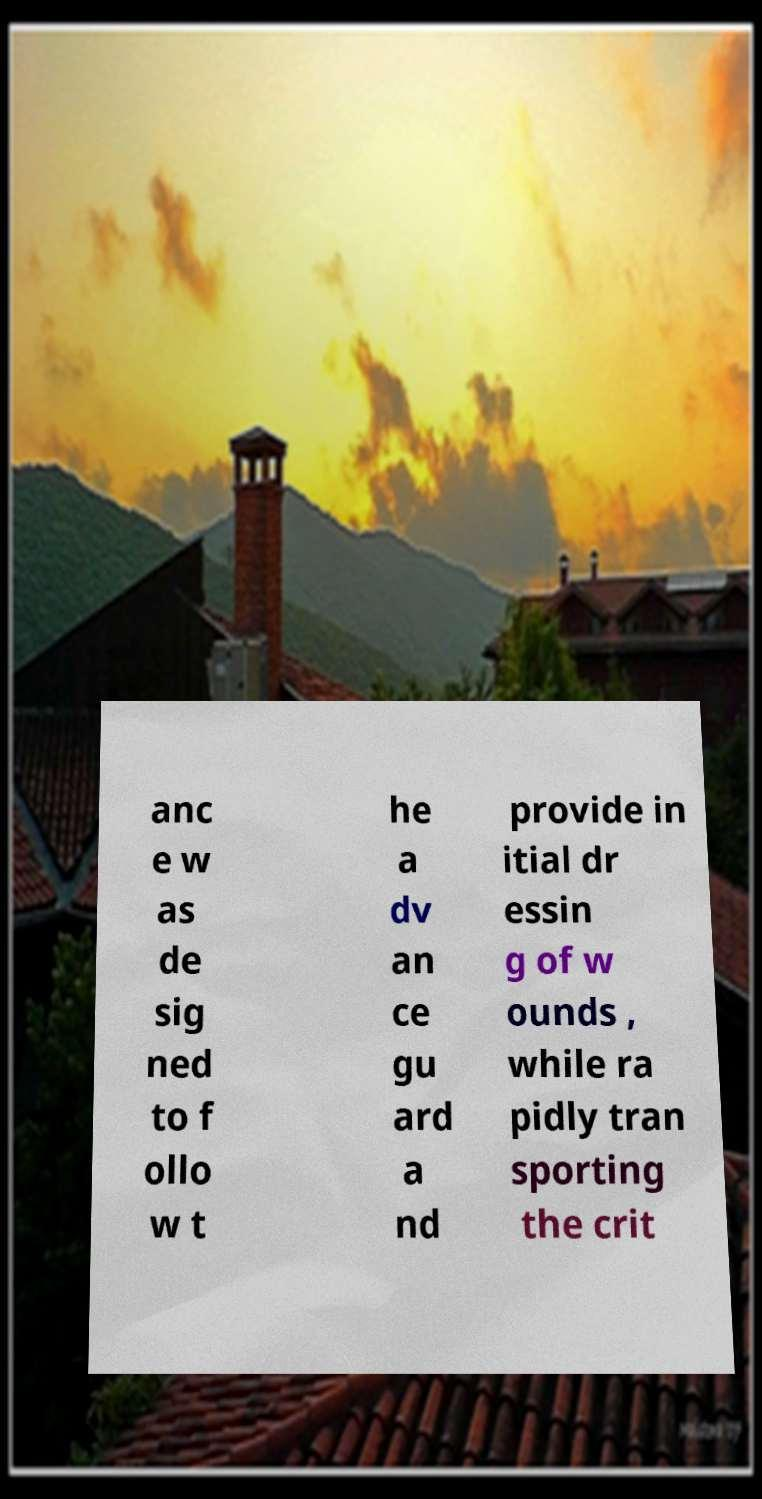What messages or text are displayed in this image? I need them in a readable, typed format. anc e w as de sig ned to f ollo w t he a dv an ce gu ard a nd provide in itial dr essin g of w ounds , while ra pidly tran sporting the crit 